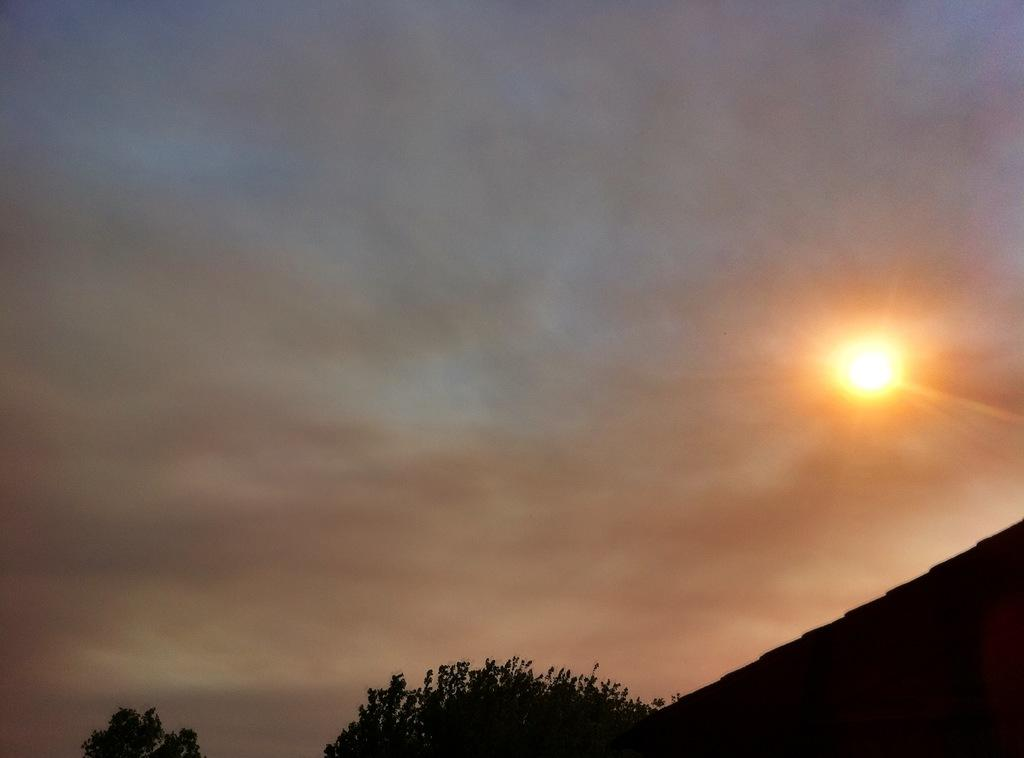Where was the image taken? The image was taken outdoors. What can be seen at the top of the image? The sky is visible at the top of the image. What is the weather like in the image? The presence of clouds and the visible sun suggest it is partly cloudy. How many trees are at the bottom of the image? There are two trees at the bottom of the image. What type of pet can be seen playing with sugar in the image? There is no pet or sugar present in the image. 